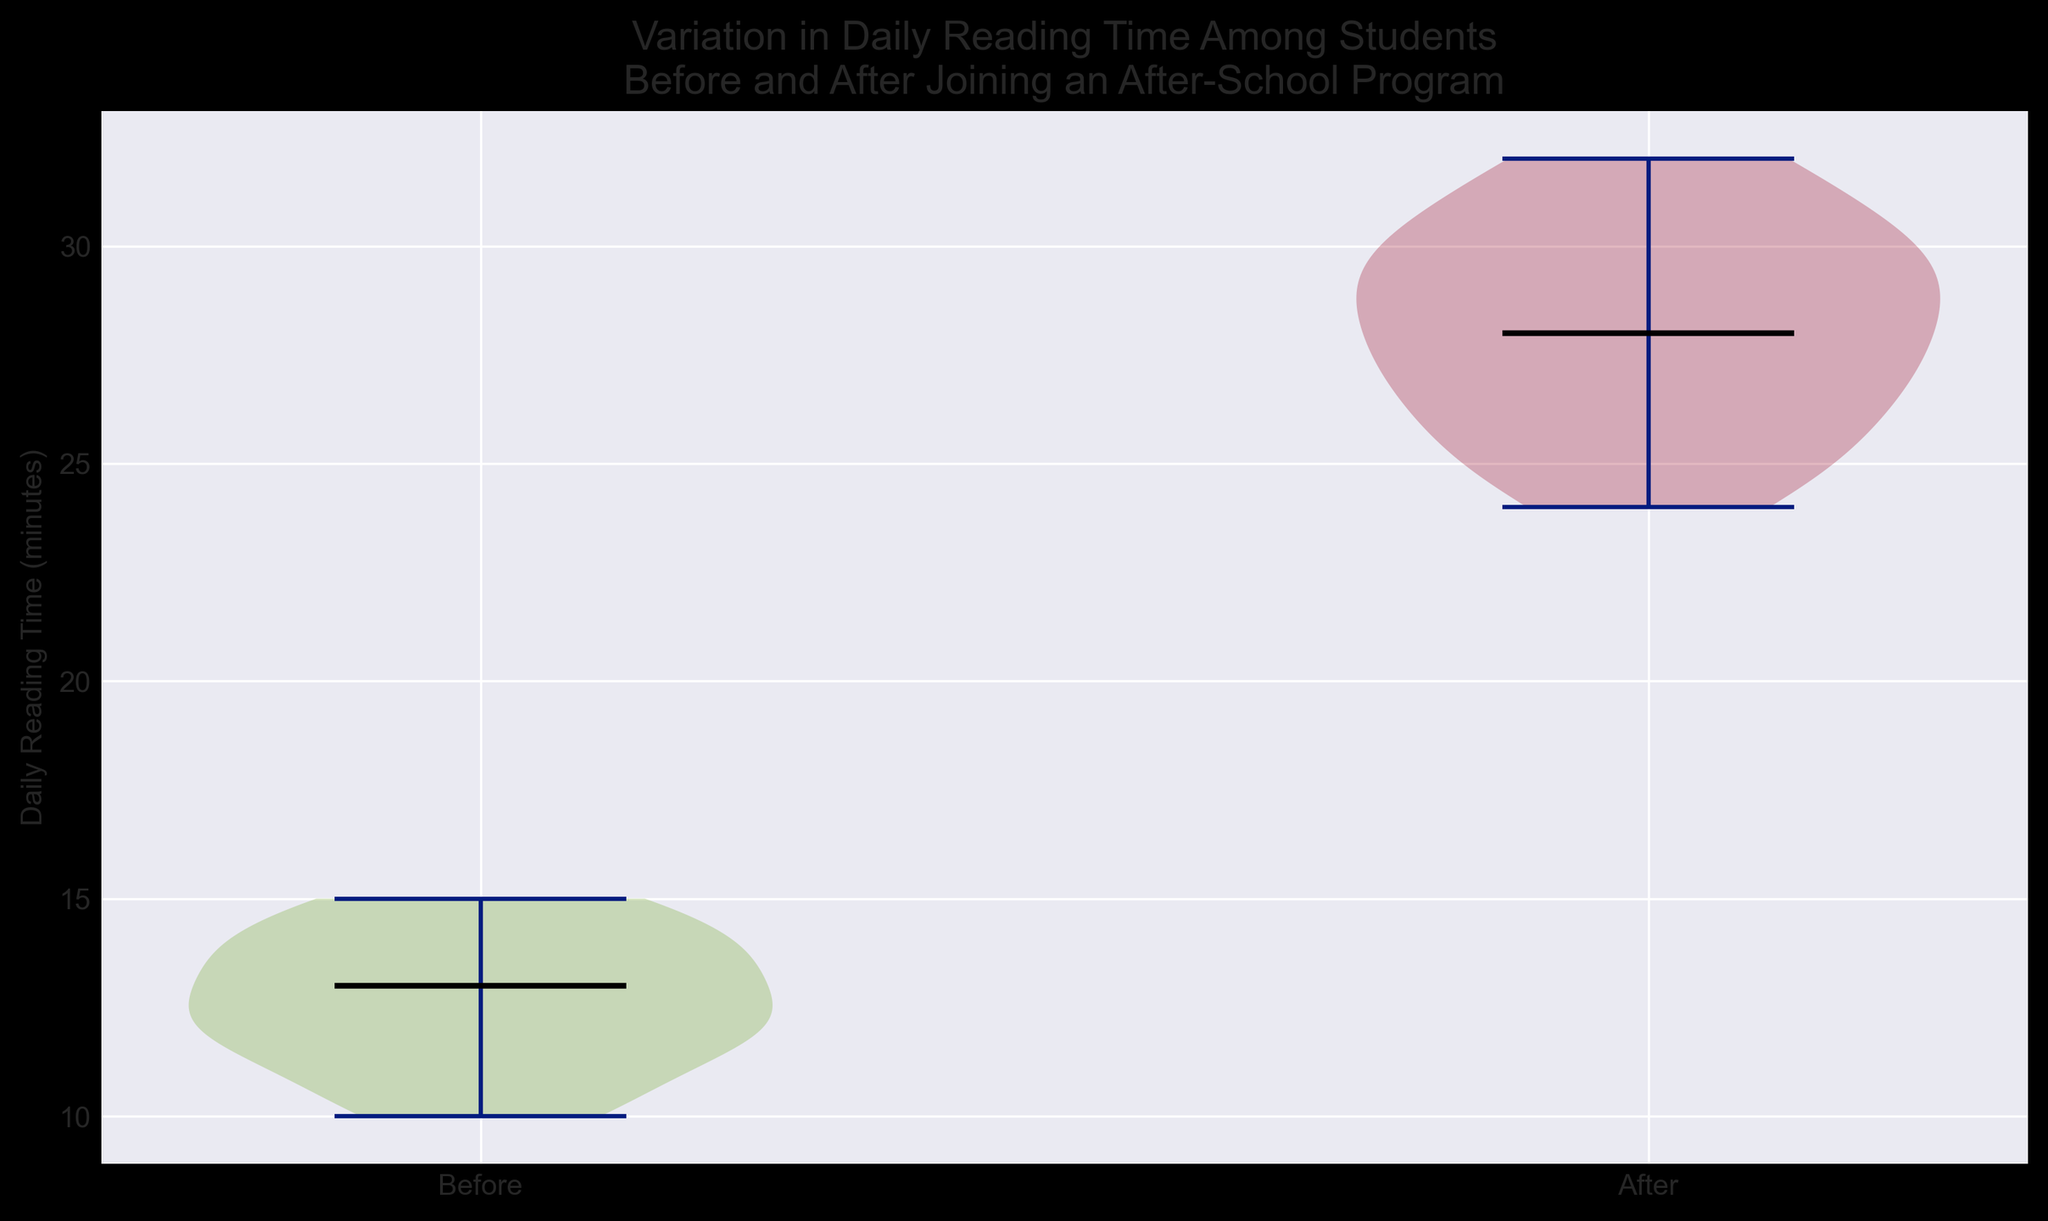What is the median daily reading time before joining the after-school program? To find the median value of the "Before" group, identify the middle value in the sorted list of daily reading times. By looking at the plot's median marker (a horizontal line in the middle of the violin plot), you can read the median value directly from the graph.
Answer: 13 minutes What is the median daily reading time after joining the after-school program? Similar to finding the median for the "Before" group, look at the median marker for the "After" group in the violin plot. Read the value from the position of the horizontal line in the middle of the violin plot.
Answer: 28 minutes How much has the median daily reading time increased after joining the after-school program? First, find the median daily reading time before and after joining the program from their respective violin plots. Then, calculate the difference between the two median values (28 minutes - 13 minutes).
Answer: 15 minutes Which group shows a wider variation in daily reading time? Look at the width of the violin plots for both "Before" and "After" groups. The wider the plot, the more variation there is in the data. Compare the widths visually.
Answer: After Are the tails of the "After" violin plot longer than those of the "Before" violin plot? The tails of a violin plot represent the extreme values (minimum and maximum) of the data. Compare the length of the tails on the "Before" and "After" plots. If the "After" plot stretches further vertically, then its tails are longer.
Answer: Yes Is there an overlap in the distribution of daily reading times between the "Before" and "After" groups? Check the range of values in both violin plots. If the "Before" and "After" plots share any common values along the y-axis, there is an overlap.
Answer: Yes What color is the area under the curve for the "Before" group? Observe the color filled within the "Before" group violin plot. It should be one consistent color throughout.
Answer: Green What color is the area under the curve for the "After" group? Similarly, look at the "After" group violin plot to see the color filled within it.
Answer: Red 